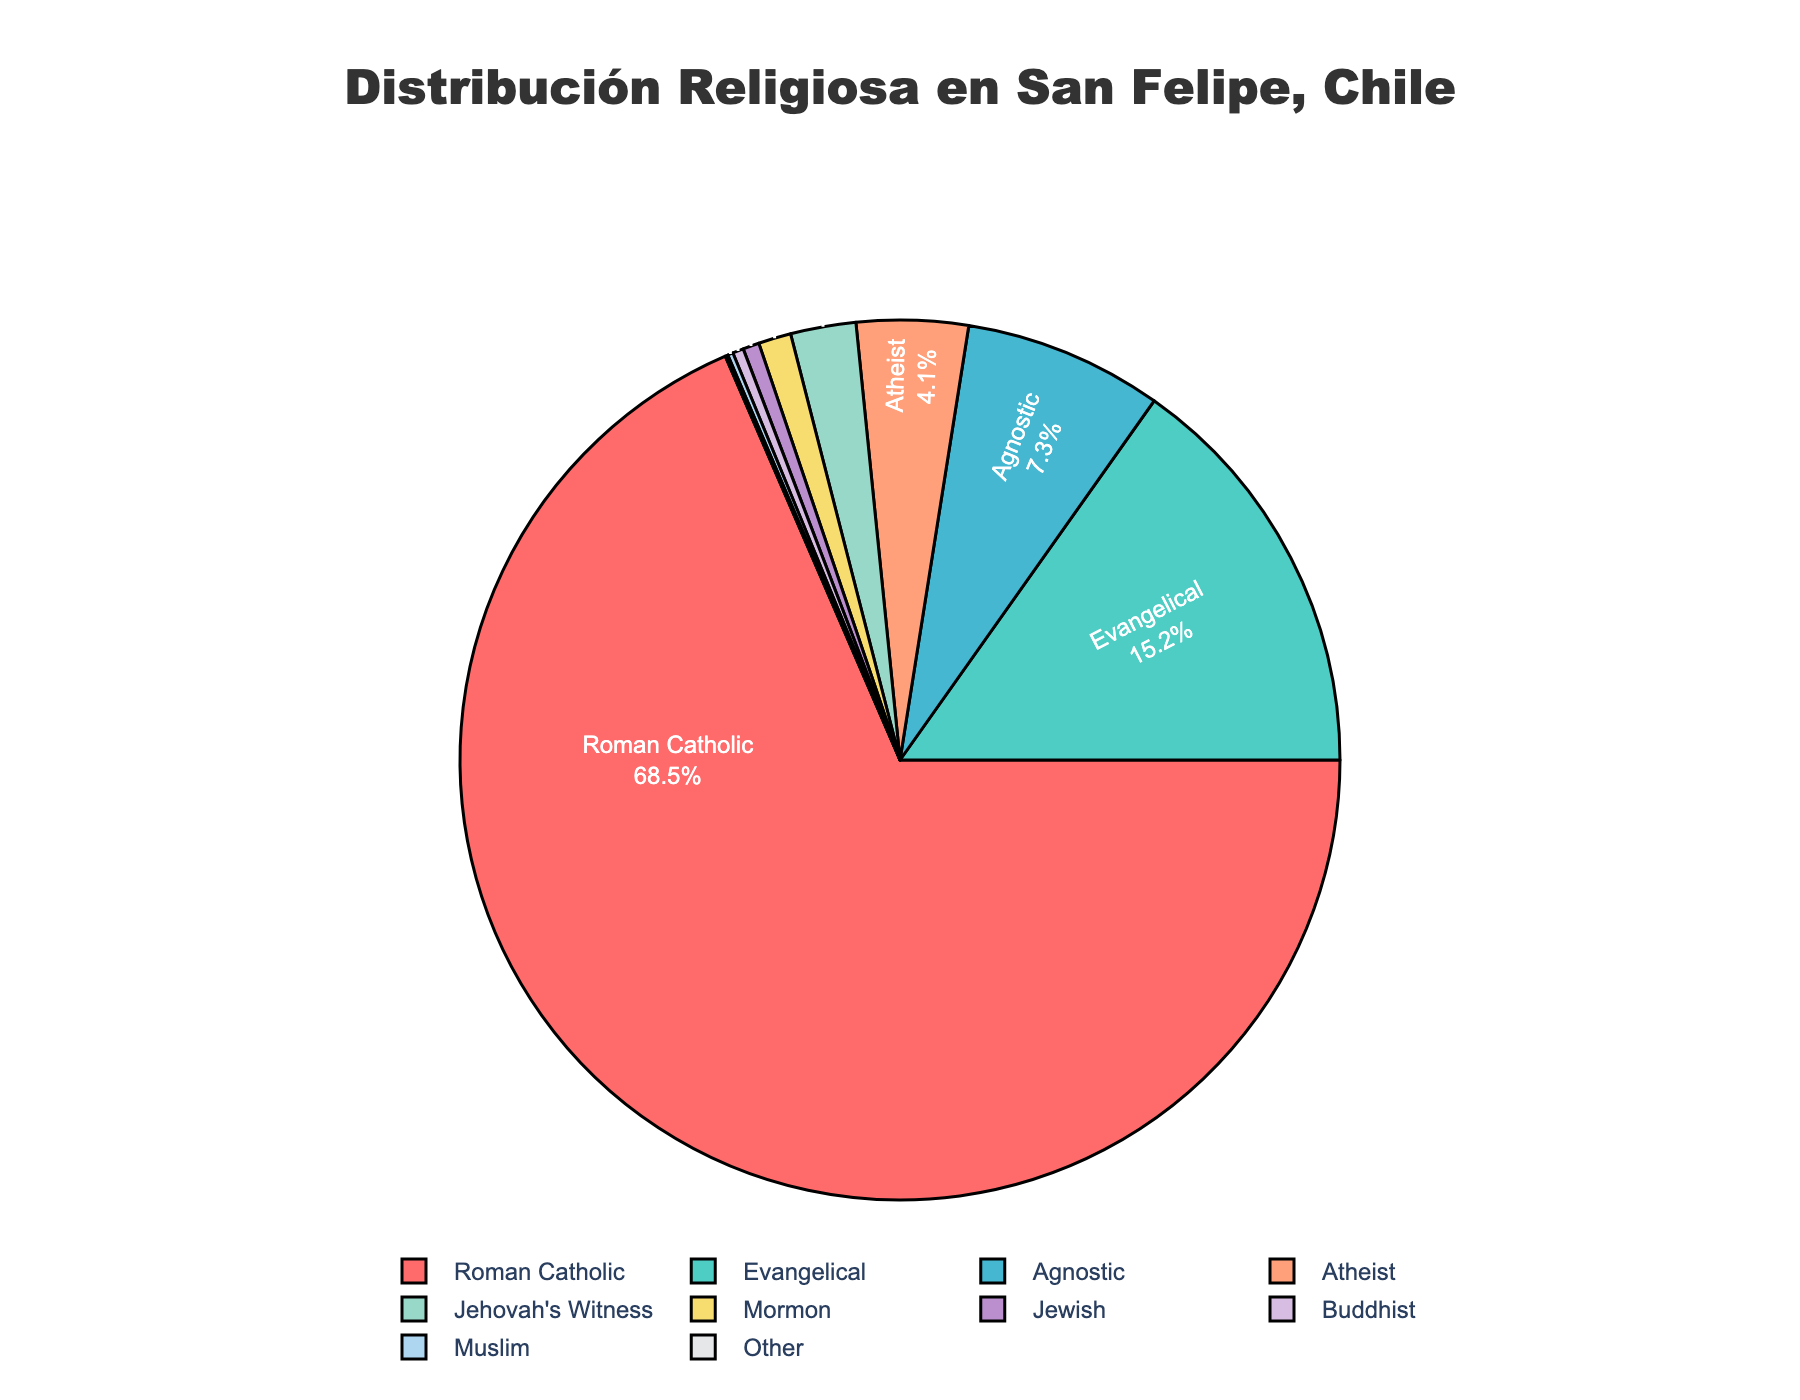What is the most common religious affiliation among residents of San Felipe? The figure shows that Roman Catholic has the largest slice of the pie chart. The label indicates that 68.5% of the population identifies as Roman Catholic.
Answer: Roman Catholic How much larger is the percentage of Roman Catholics compared to Evangelicals? The percentage of Roman Catholics is 68.5%, and Evangelicals is 15.2%. The difference is 68.5% - 15.2% = 53.3%.
Answer: 53.3% What is the combined percentage of Agnostic, Atheist, Jehovah's Witness, and Mormon residents? The percentages for Agnostic, Atheist, Jehovah's Witness, and Mormon are 7.3%, 4.1%, 2.4%, and 1.2% respectively. Adding them: 7.3 + 4.1 + 2.4 + 1.2 = 15%.
Answer: 15% Which religious group has the smallest representation and what is its percentage? The smallest slice in the pie chart is labeled as "Other," which comprises 0.1% of the population.
Answer: Other, 0.1% Are there more Agnostics or Atheists in San Felipe, and by how much? The percentage of Agnostics is 7.3% and Atheists is 4.1%. The difference is 7.3% - 4.1% = 3.2%.
Answer: Agnostics, 3.2% Are Muslims or Buddhists more prevalent in San Felipe, and what is the ratio of their percentages? The figure indicates that Muslims make up 0.2% of the population while Buddhists make up 0.4%. The ratio of Buddhist to Muslim percentages is 0.4% to 0.2%, which simplifies to 2:1.
Answer: 2:1 What is the percentage difference between the groups with the second and third highest representations? Evangelicals are second with 15.2%, and Agnostics are third with 7.3%. The difference is 15.2% - 7.3% = 7.9%.
Answer: 7.9% What is the average percentage of people in San Felipe that identify as Jewish, Buddhist, and Muslim? Adding the percentages, 0.6% (Jewish) + 0.4% (Buddhist) + 0.2% (Muslim) = 1.2%. The average is calculated by 1.2% / 3 = 0.4%.
Answer: 0.4% What portion of the population does not identify with a religion (Agnostic and Atheist combined)? The figure shows Agnostic at 7.3% and Atheist at 4.1%. Their combined portion is 7.3% + 4.1% = 11.4%.
Answer: 11.4% 